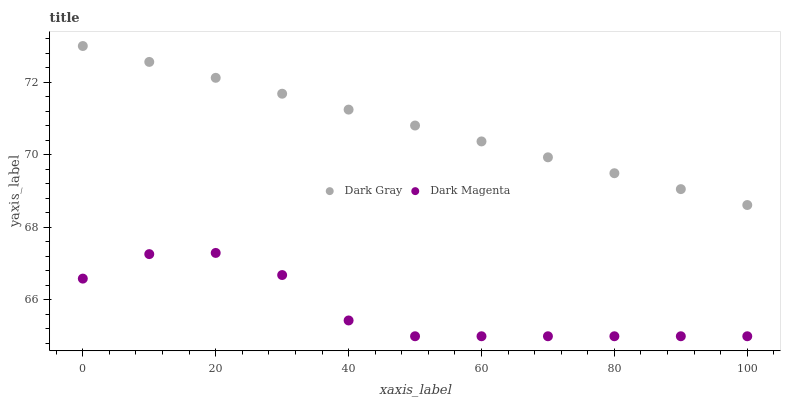Does Dark Magenta have the minimum area under the curve?
Answer yes or no. Yes. Does Dark Gray have the maximum area under the curve?
Answer yes or no. Yes. Does Dark Magenta have the maximum area under the curve?
Answer yes or no. No. Is Dark Gray the smoothest?
Answer yes or no. Yes. Is Dark Magenta the roughest?
Answer yes or no. Yes. Is Dark Magenta the smoothest?
Answer yes or no. No. Does Dark Magenta have the lowest value?
Answer yes or no. Yes. Does Dark Gray have the highest value?
Answer yes or no. Yes. Does Dark Magenta have the highest value?
Answer yes or no. No. Is Dark Magenta less than Dark Gray?
Answer yes or no. Yes. Is Dark Gray greater than Dark Magenta?
Answer yes or no. Yes. Does Dark Magenta intersect Dark Gray?
Answer yes or no. No. 